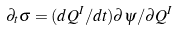Convert formula to latex. <formula><loc_0><loc_0><loc_500><loc_500>\partial _ { t } \sigma = ( d Q ^ { I } / d t ) \partial \psi / \partial Q ^ { I }</formula> 